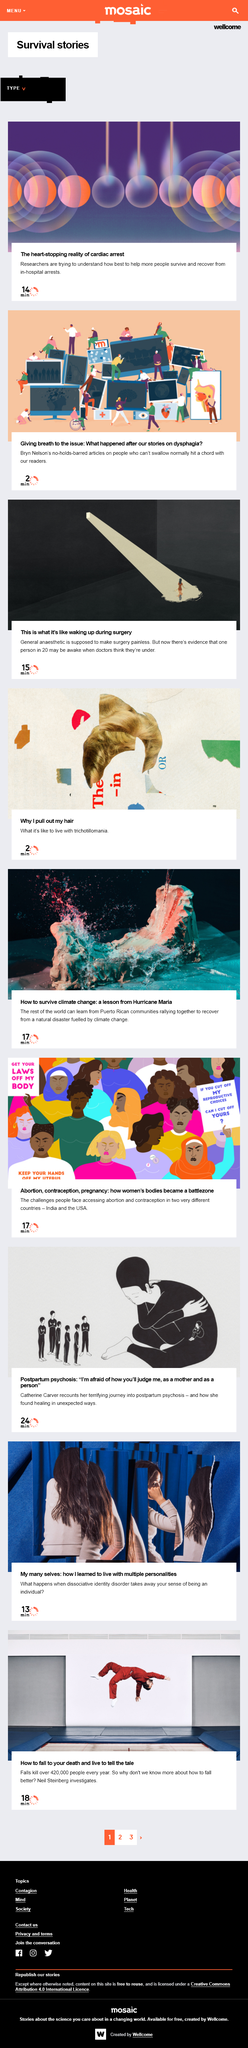Draw attention to some important aspects in this diagram. The article about postpartum psychosis is written by Catherine Carver. The author cited in the article "giving breath to the issue" is Bryn Nelson. As stated in the article "This is what it's like waking up during surgery," research suggests that approximately one in 20 patients may be aware during surgery. According to the article, it is estimated that approximately 420,000 people die each year as a result of falling. The article by Neil Steinberg discusses the topic of how to fall. 